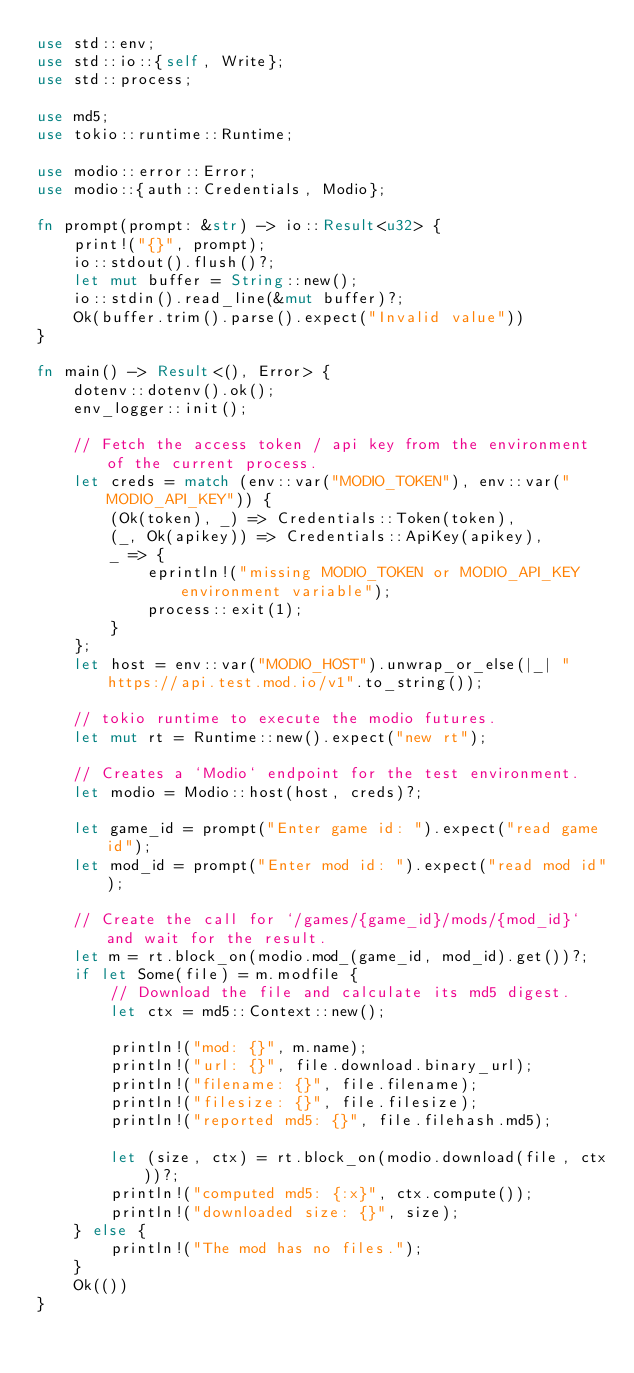<code> <loc_0><loc_0><loc_500><loc_500><_Rust_>use std::env;
use std::io::{self, Write};
use std::process;

use md5;
use tokio::runtime::Runtime;

use modio::error::Error;
use modio::{auth::Credentials, Modio};

fn prompt(prompt: &str) -> io::Result<u32> {
    print!("{}", prompt);
    io::stdout().flush()?;
    let mut buffer = String::new();
    io::stdin().read_line(&mut buffer)?;
    Ok(buffer.trim().parse().expect("Invalid value"))
}

fn main() -> Result<(), Error> {
    dotenv::dotenv().ok();
    env_logger::init();

    // Fetch the access token / api key from the environment of the current process.
    let creds = match (env::var("MODIO_TOKEN"), env::var("MODIO_API_KEY")) {
        (Ok(token), _) => Credentials::Token(token),
        (_, Ok(apikey)) => Credentials::ApiKey(apikey),
        _ => {
            eprintln!("missing MODIO_TOKEN or MODIO_API_KEY environment variable");
            process::exit(1);
        }
    };
    let host = env::var("MODIO_HOST").unwrap_or_else(|_| "https://api.test.mod.io/v1".to_string());

    // tokio runtime to execute the modio futures.
    let mut rt = Runtime::new().expect("new rt");

    // Creates a `Modio` endpoint for the test environment.
    let modio = Modio::host(host, creds)?;

    let game_id = prompt("Enter game id: ").expect("read game id");
    let mod_id = prompt("Enter mod id: ").expect("read mod id");

    // Create the call for `/games/{game_id}/mods/{mod_id}` and wait for the result.
    let m = rt.block_on(modio.mod_(game_id, mod_id).get())?;
    if let Some(file) = m.modfile {
        // Download the file and calculate its md5 digest.
        let ctx = md5::Context::new();

        println!("mod: {}", m.name);
        println!("url: {}", file.download.binary_url);
        println!("filename: {}", file.filename);
        println!("filesize: {}", file.filesize);
        println!("reported md5: {}", file.filehash.md5);

        let (size, ctx) = rt.block_on(modio.download(file, ctx))?;
        println!("computed md5: {:x}", ctx.compute());
        println!("downloaded size: {}", size);
    } else {
        println!("The mod has no files.");
    }
    Ok(())
}
</code> 